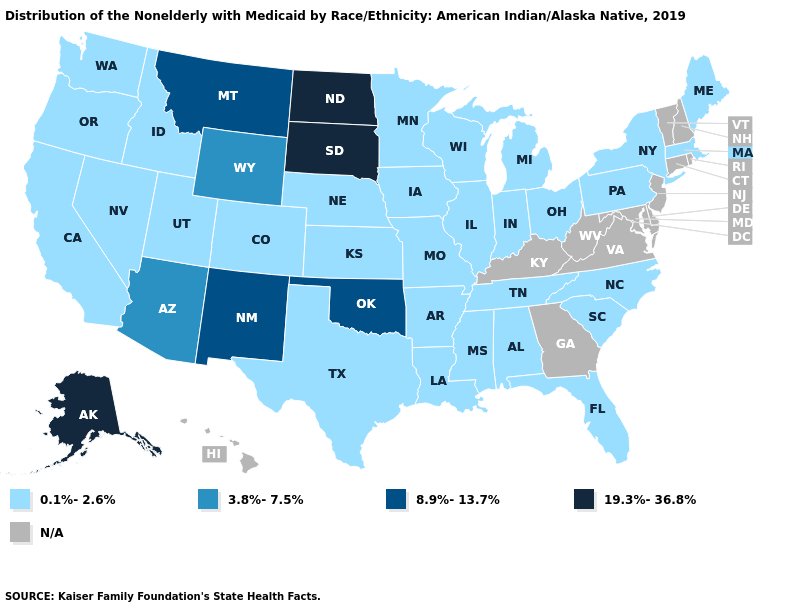What is the highest value in the USA?
Write a very short answer. 19.3%-36.8%. What is the value of Arizona?
Write a very short answer. 3.8%-7.5%. What is the value of Nebraska?
Give a very brief answer. 0.1%-2.6%. Does Montana have the lowest value in the USA?
Answer briefly. No. Name the states that have a value in the range N/A?
Write a very short answer. Connecticut, Delaware, Georgia, Hawaii, Kentucky, Maryland, New Hampshire, New Jersey, Rhode Island, Vermont, Virginia, West Virginia. What is the lowest value in states that border Colorado?
Concise answer only. 0.1%-2.6%. Among the states that border Colorado , which have the lowest value?
Keep it brief. Kansas, Nebraska, Utah. What is the value of Idaho?
Give a very brief answer. 0.1%-2.6%. Does North Dakota have the lowest value in the USA?
Answer briefly. No. What is the value of Minnesota?
Concise answer only. 0.1%-2.6%. Name the states that have a value in the range 8.9%-13.7%?
Answer briefly. Montana, New Mexico, Oklahoma. What is the value of Pennsylvania?
Answer briefly. 0.1%-2.6%. 